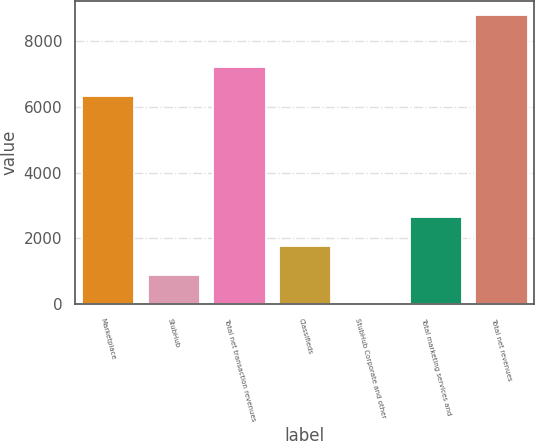<chart> <loc_0><loc_0><loc_500><loc_500><bar_chart><fcel>Marketplace<fcel>StubHub<fcel>Total net transaction revenues<fcel>Classifieds<fcel>StubHub Corporate and other<fcel>Total marketing services and<fcel>Total net revenues<nl><fcel>6351<fcel>887.1<fcel>7229.1<fcel>1765.2<fcel>9<fcel>2643.3<fcel>8790<nl></chart> 